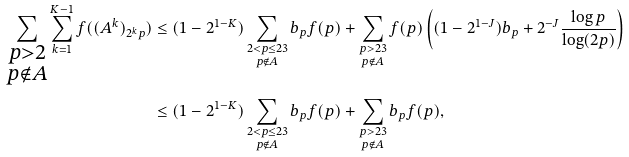<formula> <loc_0><loc_0><loc_500><loc_500>\sum _ { \substack { p > 2 \\ p \notin A } } \sum _ { k = 1 } ^ { K - 1 } f ( ( A ^ { k } ) _ { 2 ^ { k } p } ) & \leq ( 1 - 2 ^ { 1 - K } ) \sum _ { \substack { 2 < p \leq 2 3 \\ p \notin A } } b _ { p } f ( p ) + \sum _ { \substack { p > 2 3 \\ p \notin A } } f ( p ) \left ( ( 1 - 2 ^ { 1 - J } ) b _ { p } + 2 ^ { - J } \frac { \log p } { \log ( 2 p ) } \right ) \\ & \leq ( 1 - 2 ^ { 1 - K } ) \sum _ { \substack { 2 < p \leq 2 3 \\ p \notin A } } b _ { p } f ( p ) + \sum _ { \substack { p > 2 3 \\ p \notin A } } b _ { p } f ( p ) ,</formula> 